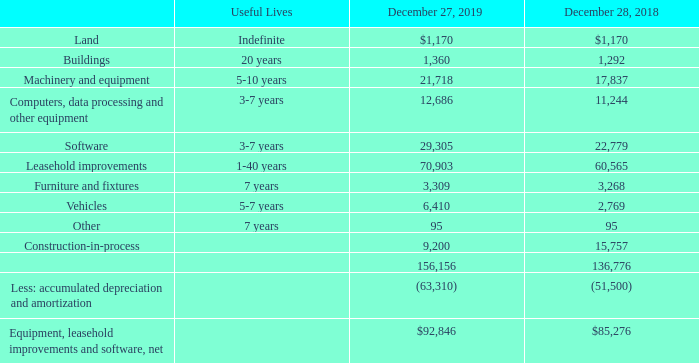Note 7 – Equipment, Leasehold Improvements and Software
Equipment, leasehold improvements and software as of December 27, 2019 and December 28, 2018 consisted of the following:
Construction-in-process at December 27, 2019 related primarily to the implementation of the Company’s Enterprise Resource Planning (“ERP”) system and at December 28, 2018 related primarily to the implementation of the Company’s ERP system and the buildout of the Company’s headquarters in Ridgefield, CT. The buildout of the Company’s headquarters was completed during fiscal 2019. The rollout of its ERP system will continue through fiscal 2020. The net book value of equipment financed under finance leases at December 27, 2019 and December 28, 2018 was $3,905 and $388, respectively. No interest expense was capitalized during the fiscal years ended December 27, 2019, December 28, 2018 and December 29, 2017.
What is the useful lives of buildings? 20 years. What is the useful lives of Machinery and equipment? 5-10 years. What is the useful lives of Computers, data processing and other equipment? 3-7 years. What is the difference in useful lives between buildings and that of Furniture and fixtures? 20-7
Answer: 13. What is the average value of vehicles for 2018 and 2019? (6,410+2,769)/2
Answer: 4589.5. What is the average value of buildings for 2018 and 2019? (1,360+ 1,292)/2
Answer: 1326. 